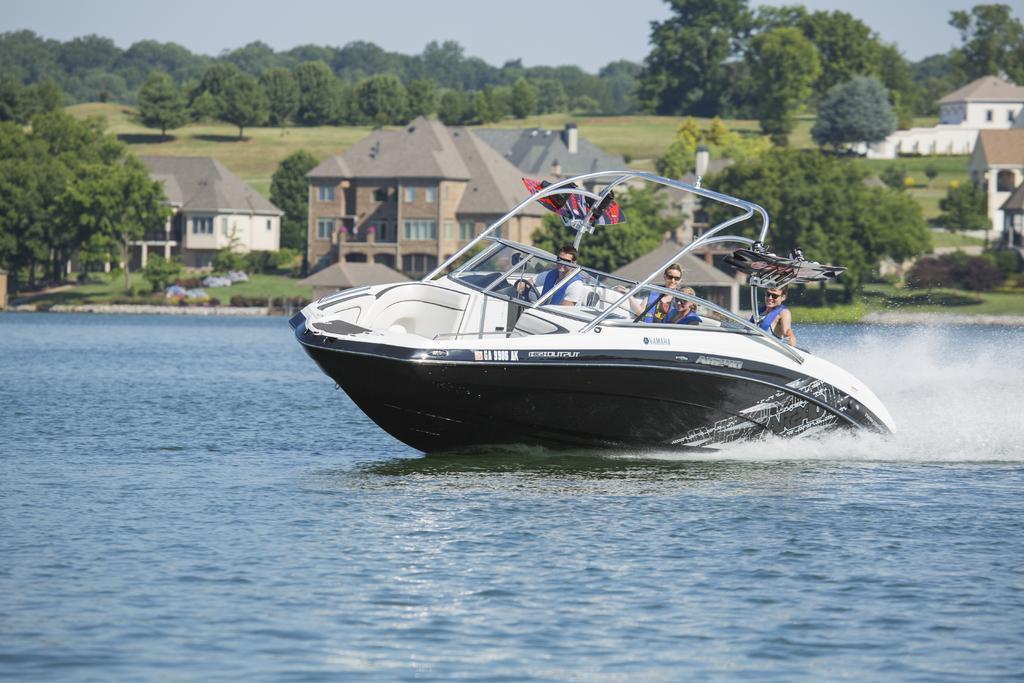In one or two sentences, can you explain what this image depicts? In this image we can see the boat in the water. And we can see the people. And we can see the grass, plants and surrounding trees. And we can see the buildings. And we can see the sky. 